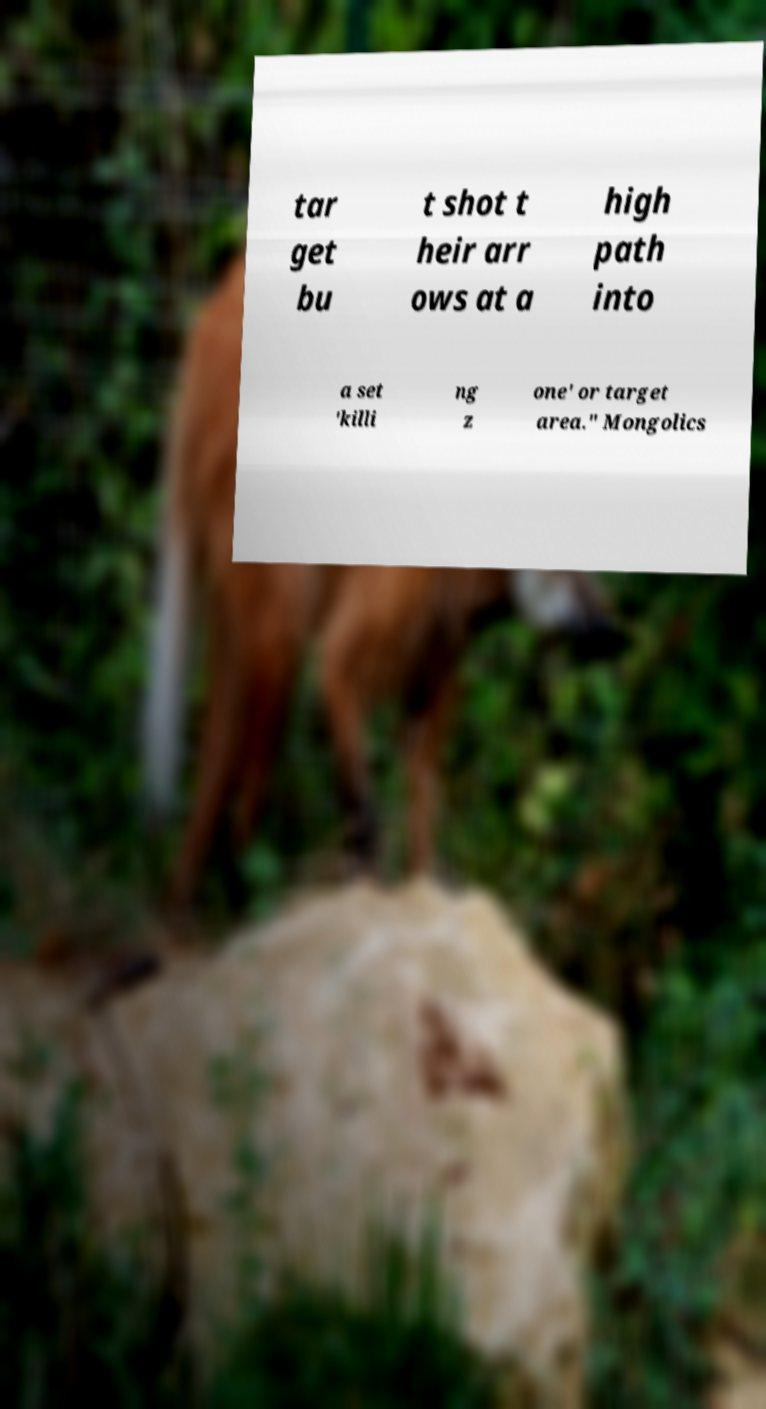Please identify and transcribe the text found in this image. tar get bu t shot t heir arr ows at a high path into a set 'killi ng z one' or target area." Mongolics 